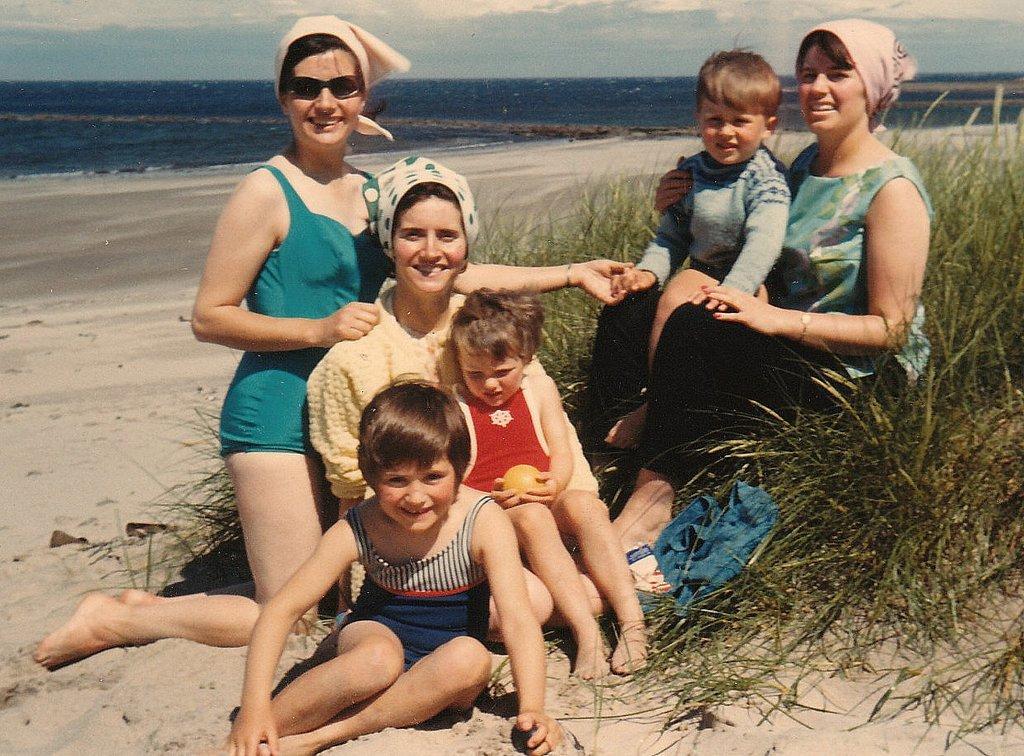In one or two sentences, can you explain what this image depicts? In the foreground, I can see six persons on grass. In the background, I can see water and the sky. This image might be taken on the sandy beach. 